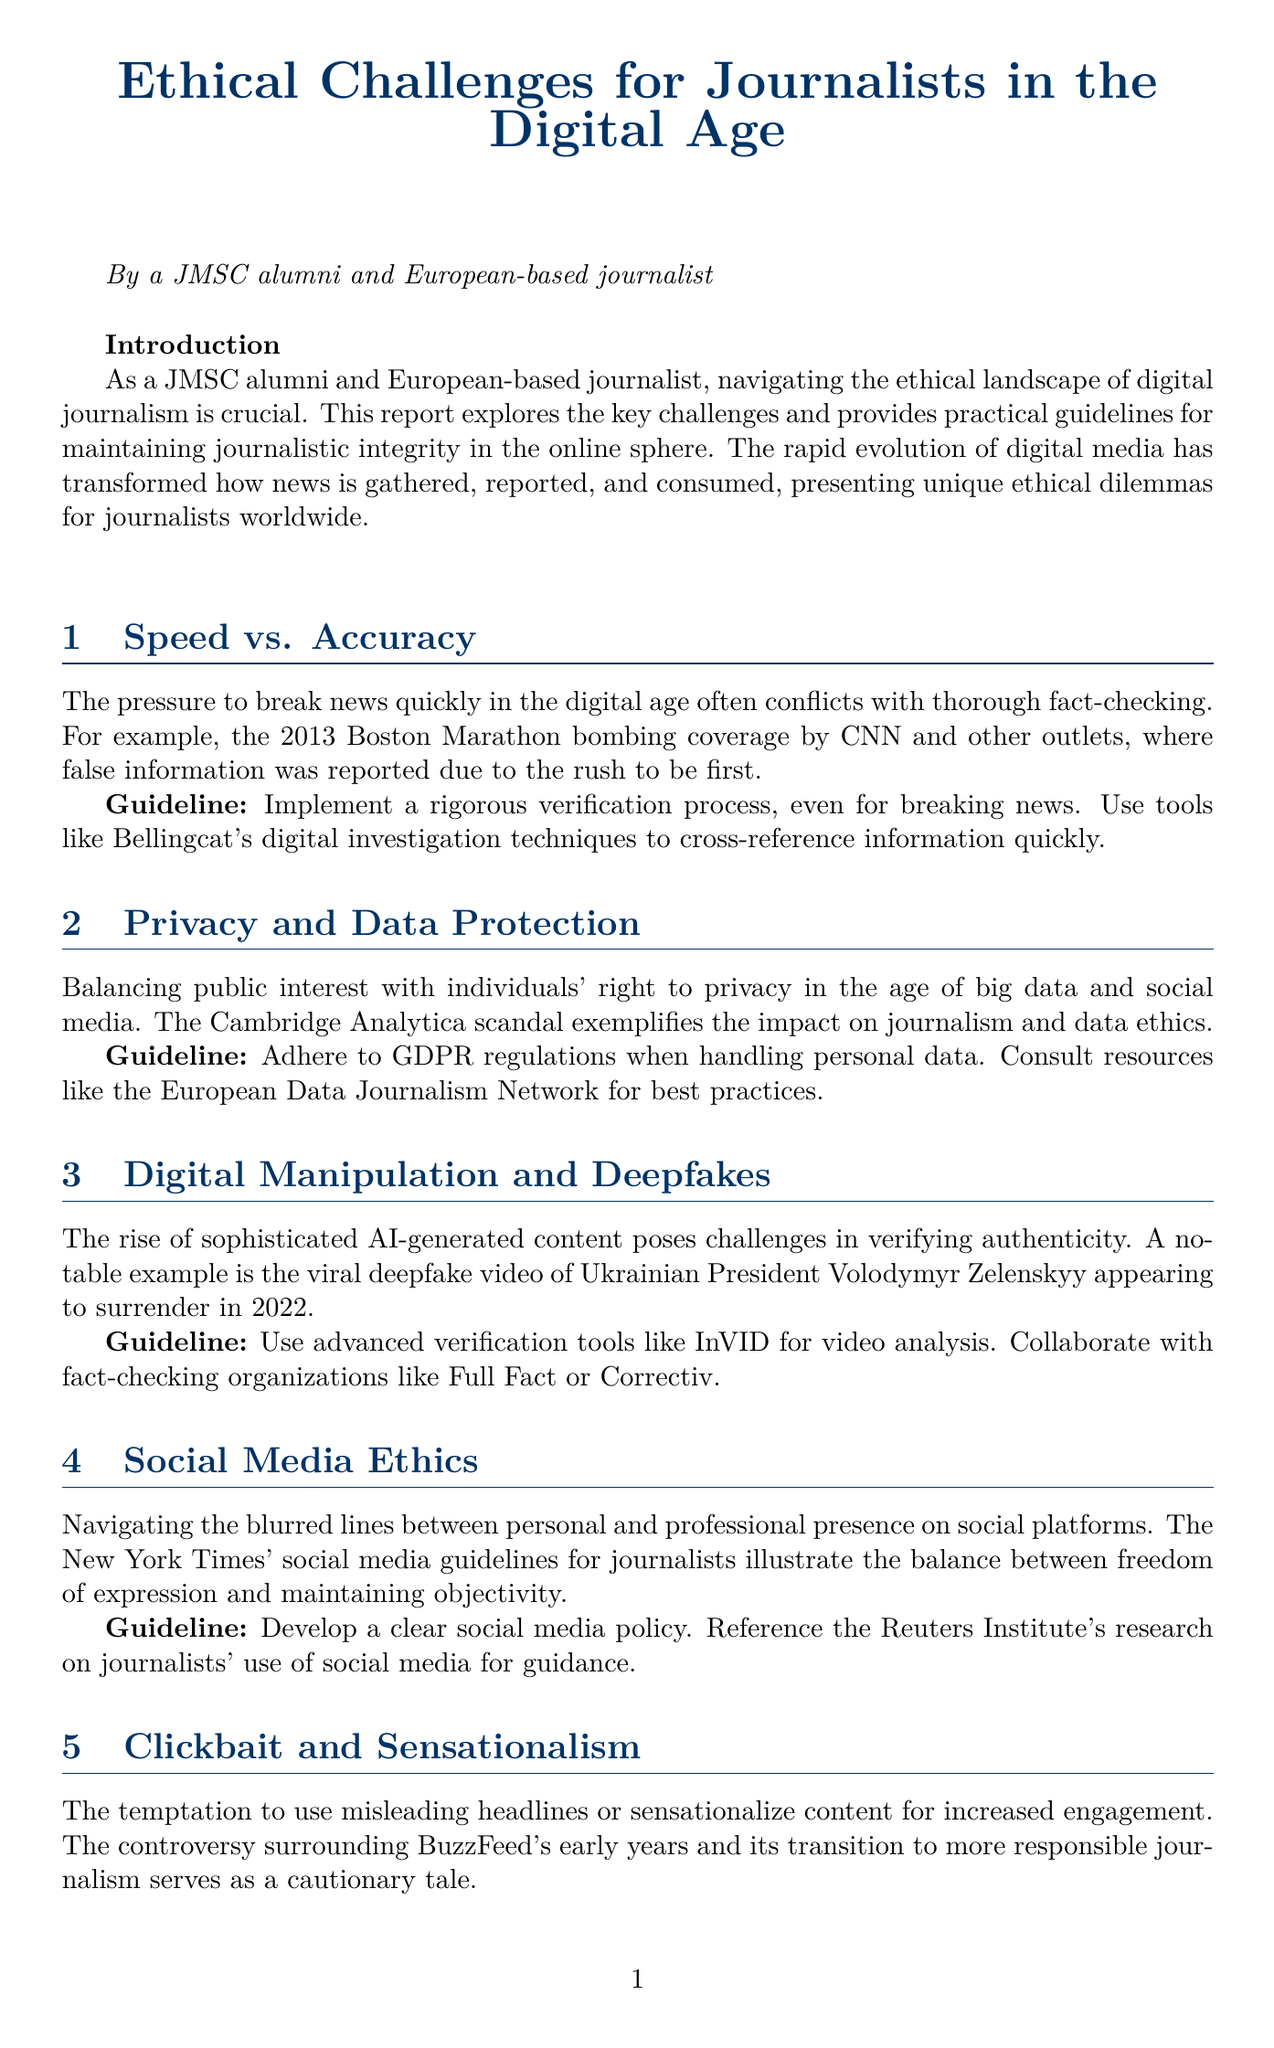what is the title of the report? The title of the report is presented at the top of the document, summarizing its main theme.
Answer: Ethical Challenges for Journalists in the Digital Age who authored the report? The author of the report is mentioned in the introduction, indicating their background and experience.
Answer: A JMSC alumni and European-based journalist what is one ethical challenge mentioned in the report? Key challenges are listed in the main sections, reflecting the issues faced by journalists today.
Answer: Speed vs. Accuracy what is the example cited for Digital Manipulation and Deepfakes? The report provides a specific instance to illustrate the ethical concerns regarding digital authenticity.
Answer: The viral deepfake video of Ukrainian President Volodymyr Zelenskyy appearing to surrender in 2022 which guideline advises on handling privacy? Guidelines are offered to help journalists navigate ethical challenges, particularly regarding sensitive information.
Answer: Adhere to GDPR regulations when handling personal data name one case study included in the report. Case studies provide practical examples and ethical considerations for journalists, enhancing the depth of the report's content.
Answer: The Panama Papers how many practical guidelines are provided? The document lists a specific number of practical guidelines aimed at improving journalistic practices in the digital age.
Answer: Five what call to action is mentioned in the conclusion? The conclusion emphasizes actions journalists can take to stay informed about ethical issues in their field.
Answer: Stay informed about emerging ethical issues 